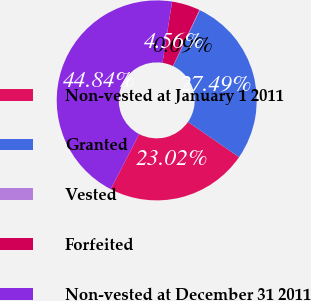Convert chart to OTSL. <chart><loc_0><loc_0><loc_500><loc_500><pie_chart><fcel>Non-vested at January 1 2011<fcel>Granted<fcel>Vested<fcel>Forfeited<fcel>Non-vested at December 31 2011<nl><fcel>23.02%<fcel>27.49%<fcel>0.09%<fcel>4.56%<fcel>44.84%<nl></chart> 